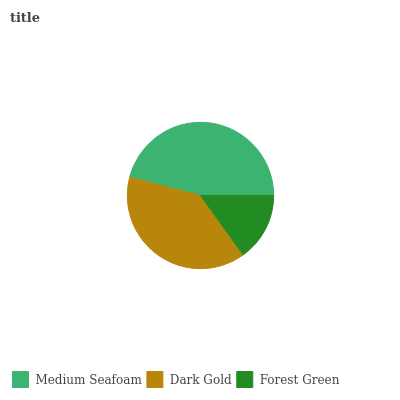Is Forest Green the minimum?
Answer yes or no. Yes. Is Medium Seafoam the maximum?
Answer yes or no. Yes. Is Dark Gold the minimum?
Answer yes or no. No. Is Dark Gold the maximum?
Answer yes or no. No. Is Medium Seafoam greater than Dark Gold?
Answer yes or no. Yes. Is Dark Gold less than Medium Seafoam?
Answer yes or no. Yes. Is Dark Gold greater than Medium Seafoam?
Answer yes or no. No. Is Medium Seafoam less than Dark Gold?
Answer yes or no. No. Is Dark Gold the high median?
Answer yes or no. Yes. Is Dark Gold the low median?
Answer yes or no. Yes. Is Medium Seafoam the high median?
Answer yes or no. No. Is Forest Green the low median?
Answer yes or no. No. 